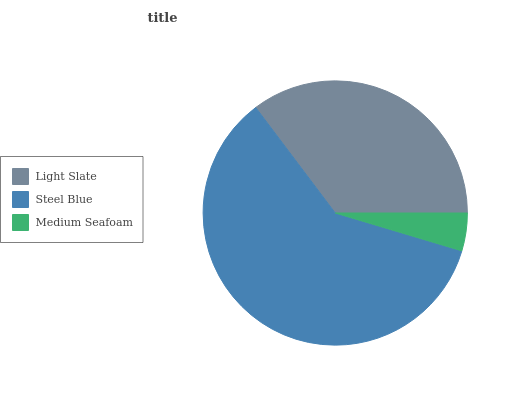Is Medium Seafoam the minimum?
Answer yes or no. Yes. Is Steel Blue the maximum?
Answer yes or no. Yes. Is Steel Blue the minimum?
Answer yes or no. No. Is Medium Seafoam the maximum?
Answer yes or no. No. Is Steel Blue greater than Medium Seafoam?
Answer yes or no. Yes. Is Medium Seafoam less than Steel Blue?
Answer yes or no. Yes. Is Medium Seafoam greater than Steel Blue?
Answer yes or no. No. Is Steel Blue less than Medium Seafoam?
Answer yes or no. No. Is Light Slate the high median?
Answer yes or no. Yes. Is Light Slate the low median?
Answer yes or no. Yes. Is Medium Seafoam the high median?
Answer yes or no. No. Is Steel Blue the low median?
Answer yes or no. No. 